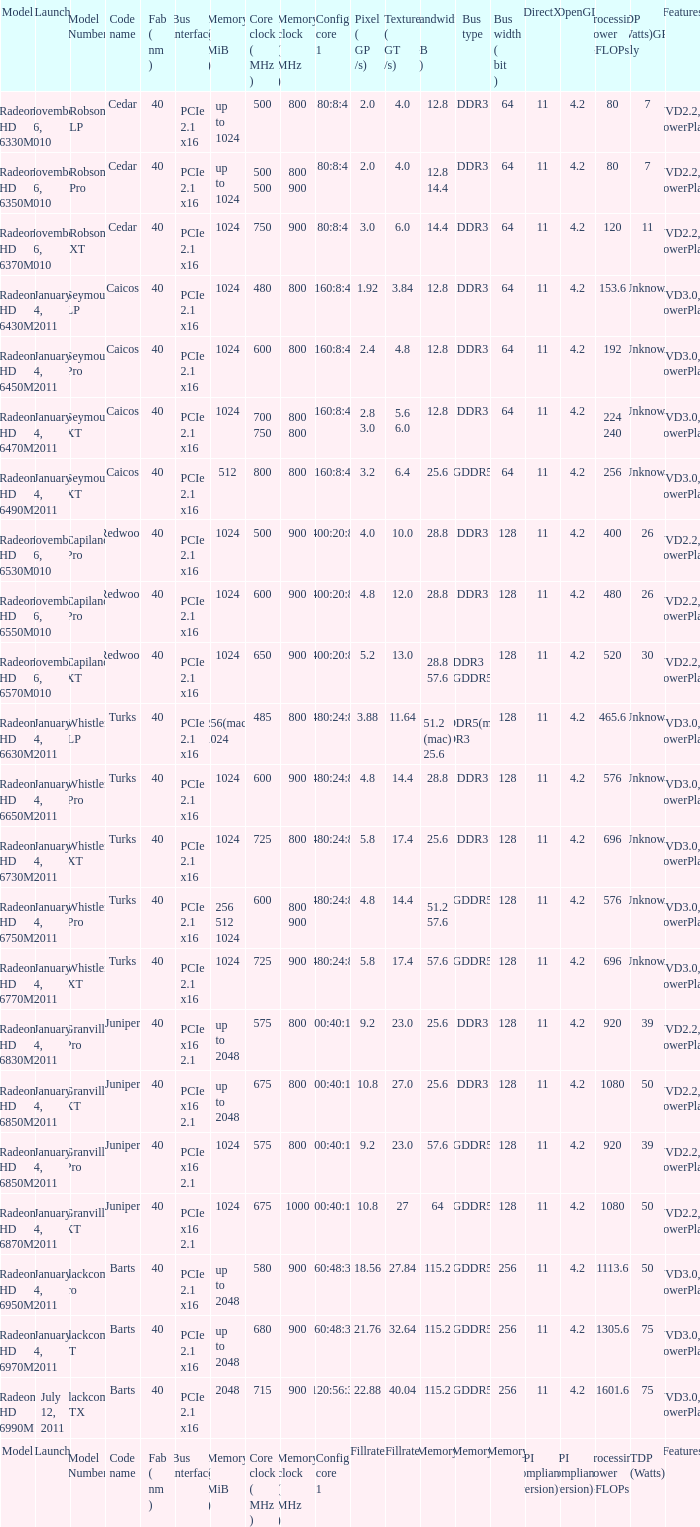How many values for fab(nm) if the model number is Whistler LP? 1.0. 